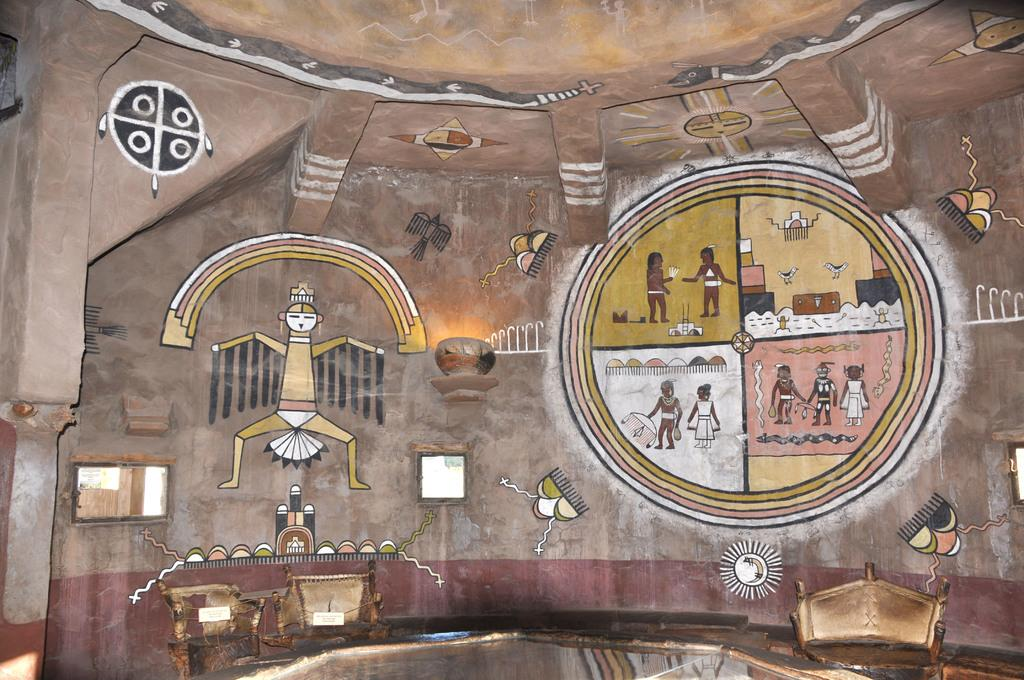What is on the wall in the image? There is a wall with paintings in the image. What do the paintings depict? The paintings depict people. Are there any other objects visible in the image besides the paintings? Yes, there are other objects visible in the image. Where is the trail that the birds are following in the image? There are no birds or trails present in the image; it features a wall with paintings depicting people. 